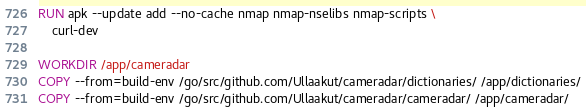Convert code to text. <code><loc_0><loc_0><loc_500><loc_500><_Dockerfile_>RUN apk --update add --no-cache nmap nmap-nselibs nmap-scripts \
    curl-dev

WORKDIR /app/cameradar
COPY --from=build-env /go/src/github.com/Ullaakut/cameradar/dictionaries/ /app/dictionaries/
COPY --from=build-env /go/src/github.com/Ullaakut/cameradar/cameradar/ /app/cameradar/</code> 